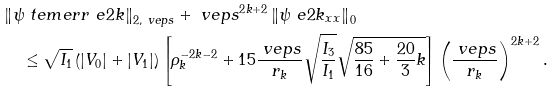<formula> <loc_0><loc_0><loc_500><loc_500>& \left \| \psi _ { \ } t e m { e r r } ^ { \ } e { 2 k } \right \| _ { 2 , \ v e p s } + \ v e p s ^ { 2 k + 2 } \left \| \psi ^ { \ } e { 2 k } _ { x x } \right \| _ { 0 } \\ & \quad \, \leq \sqrt { I _ { 1 } } \left ( | V _ { 0 } | + | V _ { 1 } | \right ) \left [ \rho _ { k } ^ { - 2 k - 2 } + 1 5 \frac { \ v e p s } { r _ { k } } \sqrt { \frac { I _ { 3 } } { I _ { 1 } } } \sqrt { \frac { 8 5 } { 1 6 } + \frac { 2 0 } { 3 } k } \right ] \left ( \frac { \ v e p s } { r _ { k } } \right ) ^ { 2 k + 2 } .</formula> 